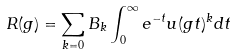Convert formula to latex. <formula><loc_0><loc_0><loc_500><loc_500>R ( g ) = \sum _ { k = 0 } B _ { k } \int _ { 0 } ^ { \infty } e ^ { - t } u ( g t ) ^ { k } d t</formula> 